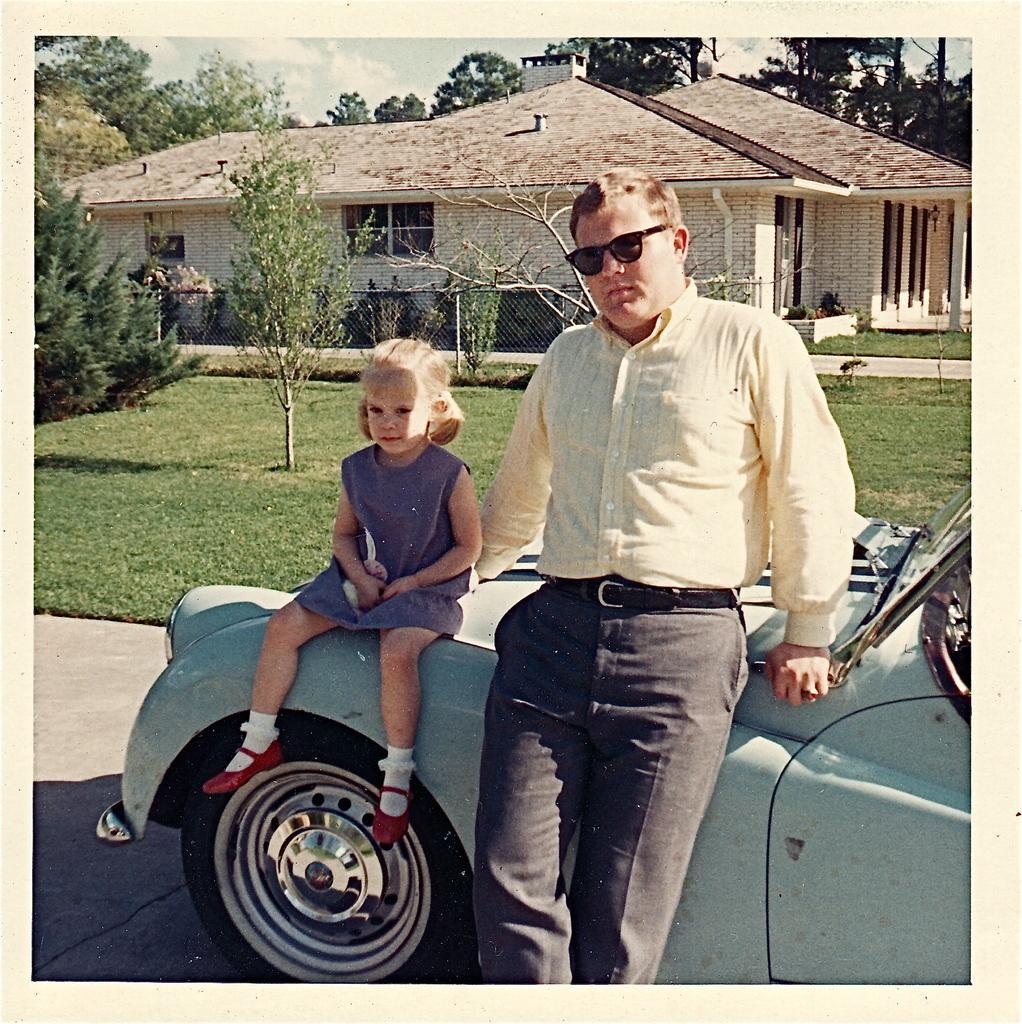Could you give a brief overview of what you see in this image? In this image there is a road. There is a car. There are two people. There is grass. There are plants. There is a house. There are trees in the background. There are clouds in the sky. 